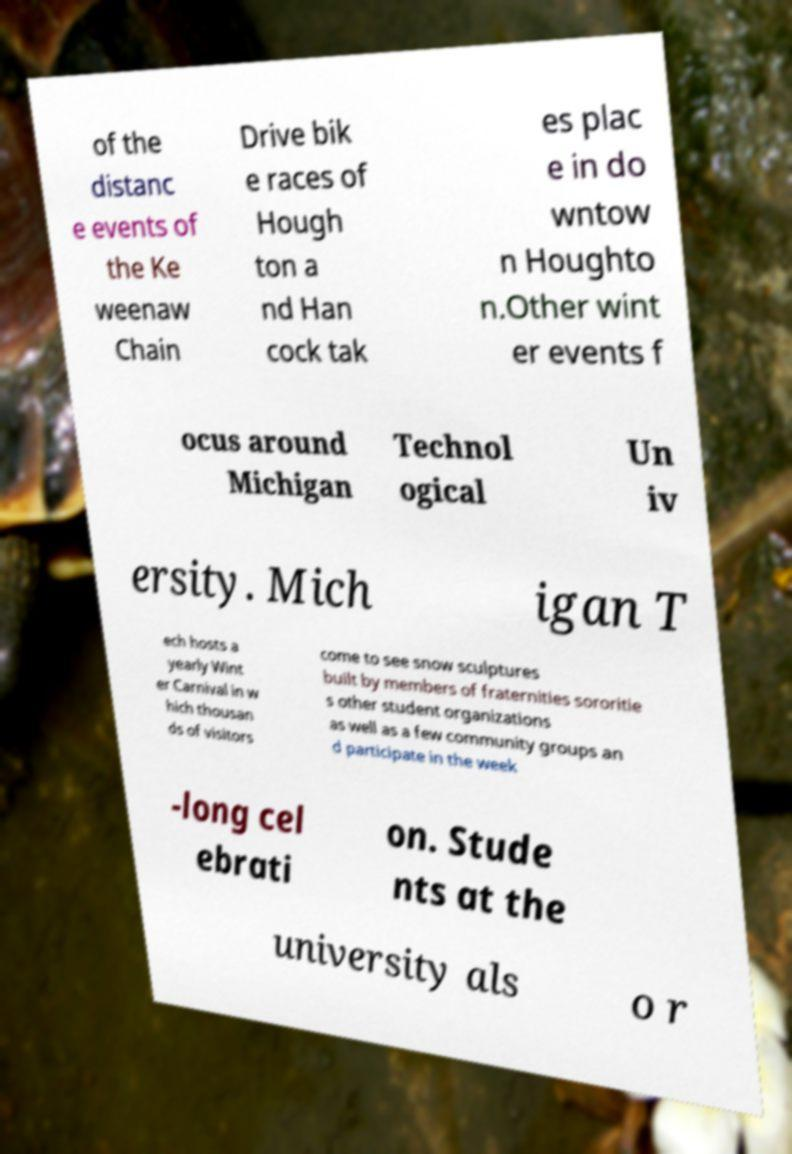Could you extract and type out the text from this image? of the distanc e events of the Ke weenaw Chain Drive bik e races of Hough ton a nd Han cock tak es plac e in do wntow n Houghto n.Other wint er events f ocus around Michigan Technol ogical Un iv ersity. Mich igan T ech hosts a yearly Wint er Carnival in w hich thousan ds of visitors come to see snow sculptures built by members of fraternities sororitie s other student organizations as well as a few community groups an d participate in the week -long cel ebrati on. Stude nts at the university als o r 